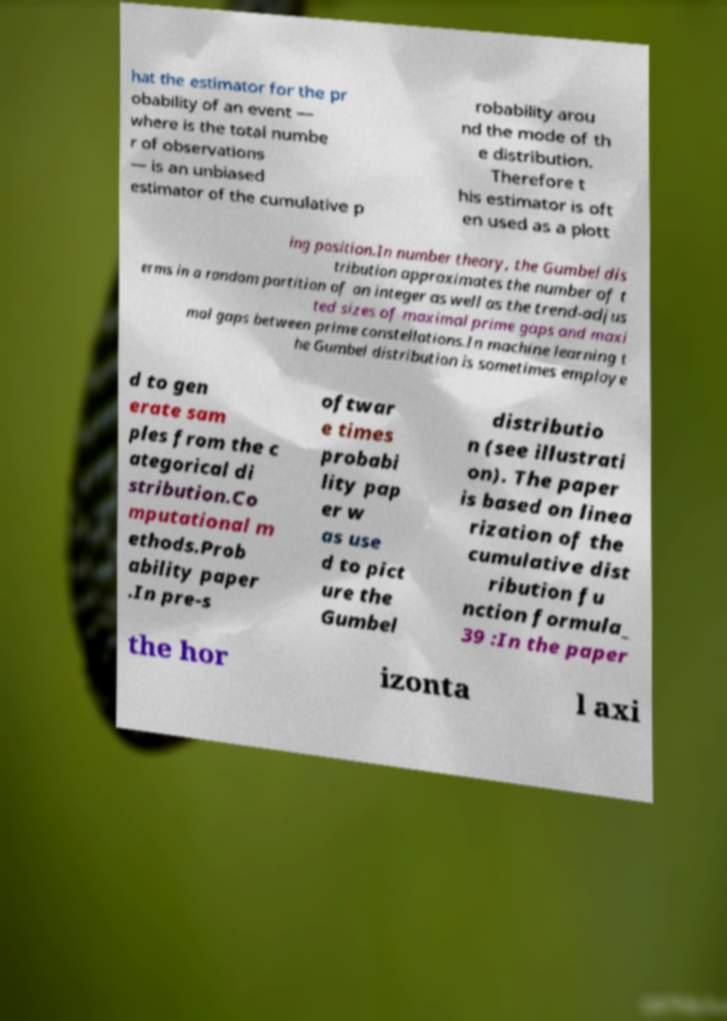What messages or text are displayed in this image? I need them in a readable, typed format. hat the estimator for the pr obability of an event — where is the total numbe r of observations — is an unbiased estimator of the cumulative p robability arou nd the mode of th e distribution. Therefore t his estimator is oft en used as a plott ing position.In number theory, the Gumbel dis tribution approximates the number of t erms in a random partition of an integer as well as the trend-adjus ted sizes of maximal prime gaps and maxi mal gaps between prime constellations.In machine learning t he Gumbel distribution is sometimes employe d to gen erate sam ples from the c ategorical di stribution.Co mputational m ethods.Prob ability paper .In pre-s oftwar e times probabi lity pap er w as use d to pict ure the Gumbel distributio n (see illustrati on). The paper is based on linea rization of the cumulative dist ribution fu nction formula_ 39 :In the paper the hor izonta l axi 